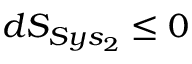<formula> <loc_0><loc_0><loc_500><loc_500>d S _ { S y s _ { 2 } } \leq 0</formula> 